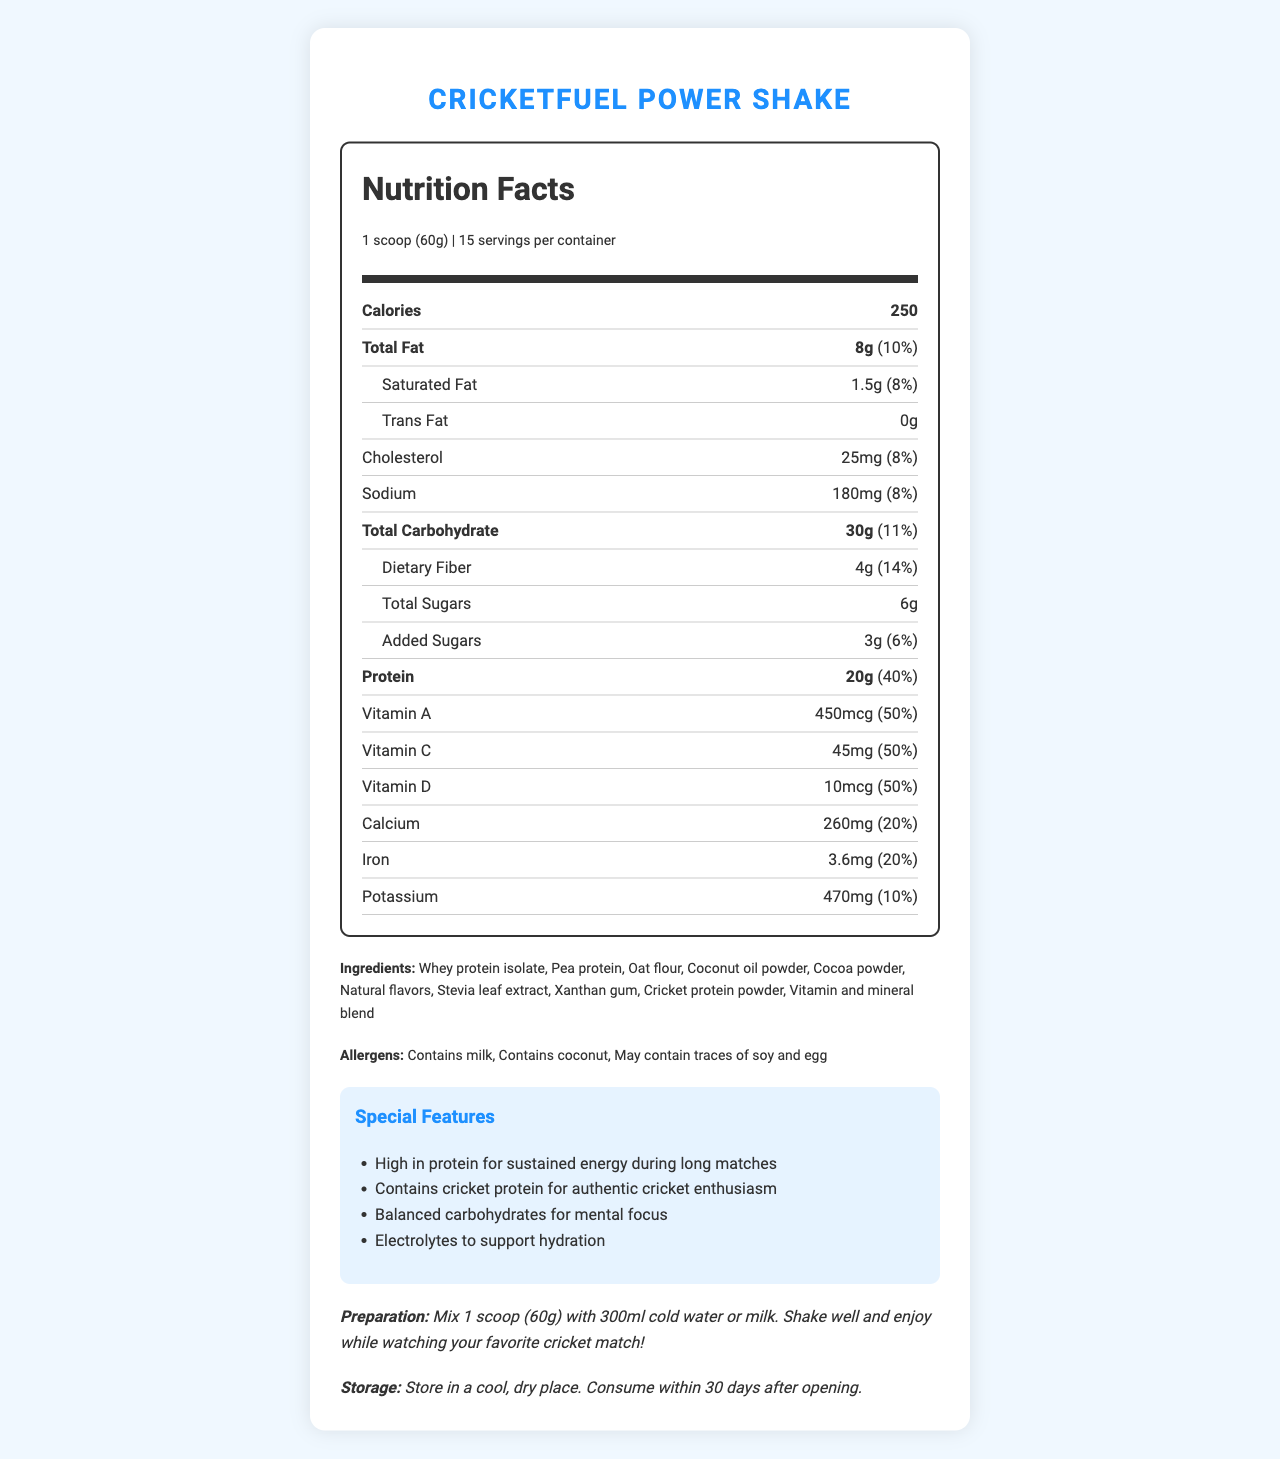What is the serving size of the CricketFuel Power Shake? The serving size is clearly stated at the beginning of the document under the product name and serving information.
Answer: 1 scoop (60g) How many servings are there per container? This information is found next to the serving size at the top of the nutrition label.
Answer: 15 servings How many calories are there per serving? The calories per serving are listed prominently in the nutrition facts section.
Answer: 250 calories How much protein does one serving contain? The amount of protein is listed within the nutrition facts section.
Answer: 20 grams What percentage of daily value is the dietary fiber content per serving? The daily value percentage for dietary fiber is provided along with its amount.
Answer: 14% Which vitamin is not listed in the CricketFuel Power Shake? A. Vitamin A B. Vitamin B12 C. Vitamin C D. Vitamin D The vitamins listed include Vitamin A, Vitamin C, and Vitamin D but not Vitamin B12.
Answer: B. Vitamin B12 Which of the following allergens is contained in the CricketFuel Power Shake? A. Peanut B. Milk C. Gluten D. Soy The allergens listed in the document state that the product contains milk, among others.
Answer: B. Milk Does the product contain added sugars? The nutrition facts section lists both total sugars and added sugars.
Answer: Yes What flavor profile is described for the CricketFuel Power Shake? The flavor profile is indicated in the document under special features.
Answer: Rich chocolate with a hint of caramel Is this product suitable for someone with a coconut allergy? The allergens section lists that the product contains coconut.
Answer: No Summarize the main idea of the document. The document is focused on presenting the comprehensive nutritional profile of the CricketFuel Power Shake, detailing the amount and percentage daily value of various nutrients, listing the ingredients, allergens, and the special features aimed to support cricket fans during long matches.
Answer: The document provides detailed nutritional information about the CricketFuel Power Shake, a cricket-themed meal replacement designed for long matches. It highlights key nutritional values, ingredients, allergens, special features, preparation instructions, and storage guidelines. How should the CricketFuel Power Shake be prepared? The preparation instructions are detailed towards the end of the document.
Answer: Mix 1 scoop (60g) with 300ml cold water or milk. Shake well and enjoy while watching your favorite cricket match! How much calcium is in one serving? The amount of calcium is listed in the nutrition facts section.
Answer: 260 mg What kind of protein is included in the shake alongside cricket protein powder? These ingredients are listed under the ingredients section.
Answer: Whey protein isolate and pea protein What is the special feature of the product related to hydration? A. Low sodium B. High fiber C. Electrolytes D. Low sugar The special features section mentions that the product contains electrolytes to support hydration.
Answer: C. Electrolytes Can the exact date when the shake was manufactured be determined? The document does not provide any information regarding the manufacturing date of the product.
Answer: Not enough information 